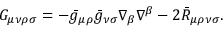<formula> <loc_0><loc_0><loc_500><loc_500>G _ { \mu \nu \rho \sigma } = - \bar { g } _ { \mu \rho } \bar { g } _ { \nu \sigma } \nabla _ { \beta } \nabla ^ { \beta } - 2 \bar { R } _ { \mu \rho \nu \sigma } .</formula> 